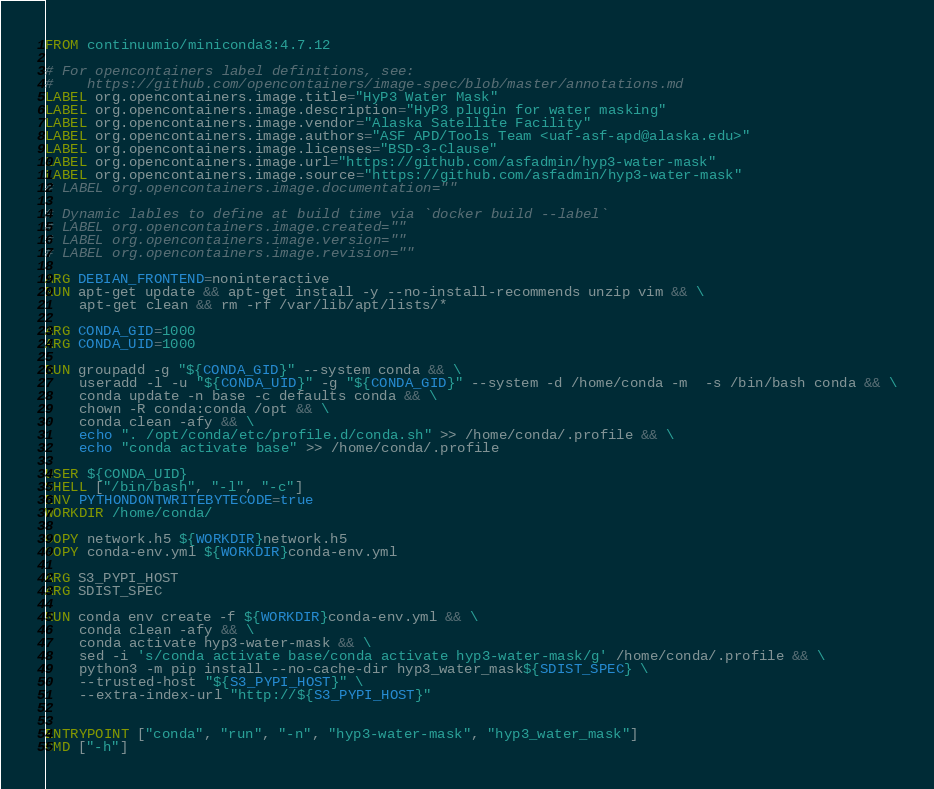Convert code to text. <code><loc_0><loc_0><loc_500><loc_500><_Dockerfile_>FROM continuumio/miniconda3:4.7.12

# For opencontainers label definitions, see:
#    https://github.com/opencontainers/image-spec/blob/master/annotations.md
LABEL org.opencontainers.image.title="HyP3 Water Mask"
LABEL org.opencontainers.image.description="HyP3 plugin for water masking"
LABEL org.opencontainers.image.vendor="Alaska Satellite Facility"
LABEL org.opencontainers.image.authors="ASF APD/Tools Team <uaf-asf-apd@alaska.edu>"
LABEL org.opencontainers.image.licenses="BSD-3-Clause"
LABEL org.opencontainers.image.url="https://github.com/asfadmin/hyp3-water-mask"
LABEL org.opencontainers.image.source="https://github.com/asfadmin/hyp3-water-mask"
# LABEL org.opencontainers.image.documentation=""

# Dynamic lables to define at build time via `docker build --label`
# LABEL org.opencontainers.image.created=""
# LABEL org.opencontainers.image.version=""
# LABEL org.opencontainers.image.revision=""

ARG DEBIAN_FRONTEND=noninteractive
RUN apt-get update && apt-get install -y --no-install-recommends unzip vim && \
    apt-get clean && rm -rf /var/lib/apt/lists/*

ARG CONDA_GID=1000
ARG CONDA_UID=1000

RUN groupadd -g "${CONDA_GID}" --system conda && \
    useradd -l -u "${CONDA_UID}" -g "${CONDA_GID}" --system -d /home/conda -m  -s /bin/bash conda && \
    conda update -n base -c defaults conda && \
    chown -R conda:conda /opt && \
    conda clean -afy && \
    echo ". /opt/conda/etc/profile.d/conda.sh" >> /home/conda/.profile && \
    echo "conda activate base" >> /home/conda/.profile

USER ${CONDA_UID}
SHELL ["/bin/bash", "-l", "-c"]
ENV PYTHONDONTWRITEBYTECODE=true
WORKDIR /home/conda/

COPY network.h5 ${WORKDIR}network.h5
COPY conda-env.yml ${WORKDIR}conda-env.yml

ARG S3_PYPI_HOST
ARG SDIST_SPEC

RUN conda env create -f ${WORKDIR}conda-env.yml && \
    conda clean -afy && \
    conda activate hyp3-water-mask && \
    sed -i 's/conda activate base/conda activate hyp3-water-mask/g' /home/conda/.profile && \
    python3 -m pip install --no-cache-dir hyp3_water_mask${SDIST_SPEC} \
    --trusted-host "${S3_PYPI_HOST}" \
    --extra-index-url "http://${S3_PYPI_HOST}"


ENTRYPOINT ["conda", "run", "-n", "hyp3-water-mask", "hyp3_water_mask"]
CMD ["-h"]

</code> 